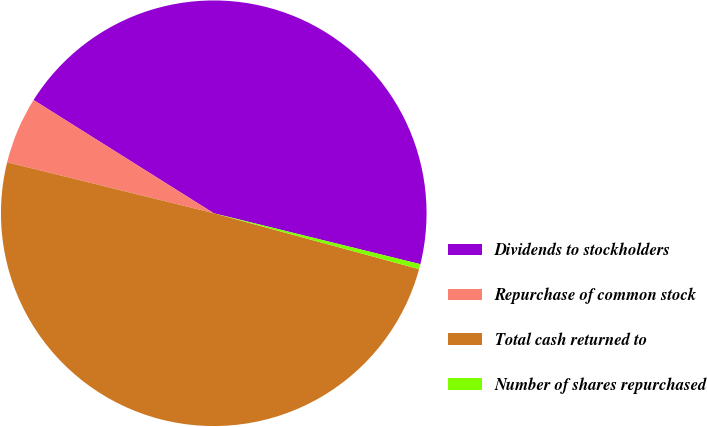<chart> <loc_0><loc_0><loc_500><loc_500><pie_chart><fcel>Dividends to stockholders<fcel>Repurchase of common stock<fcel>Total cash returned to<fcel>Number of shares repurchased<nl><fcel>44.92%<fcel>5.08%<fcel>49.62%<fcel>0.38%<nl></chart> 